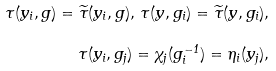<formula> <loc_0><loc_0><loc_500><loc_500>\tau ( y _ { i } , g ) = \widetilde { \tau } ( y _ { i } , g ) , \, \tau ( y , g _ { i } ) = \widetilde { \tau } ( y , g _ { i } ) , \\ \tau ( y _ { i } , g _ { j } ) = \chi _ { j } ( g _ { i } ^ { - 1 } ) = \eta _ { i } ( y _ { j } ) ,</formula> 